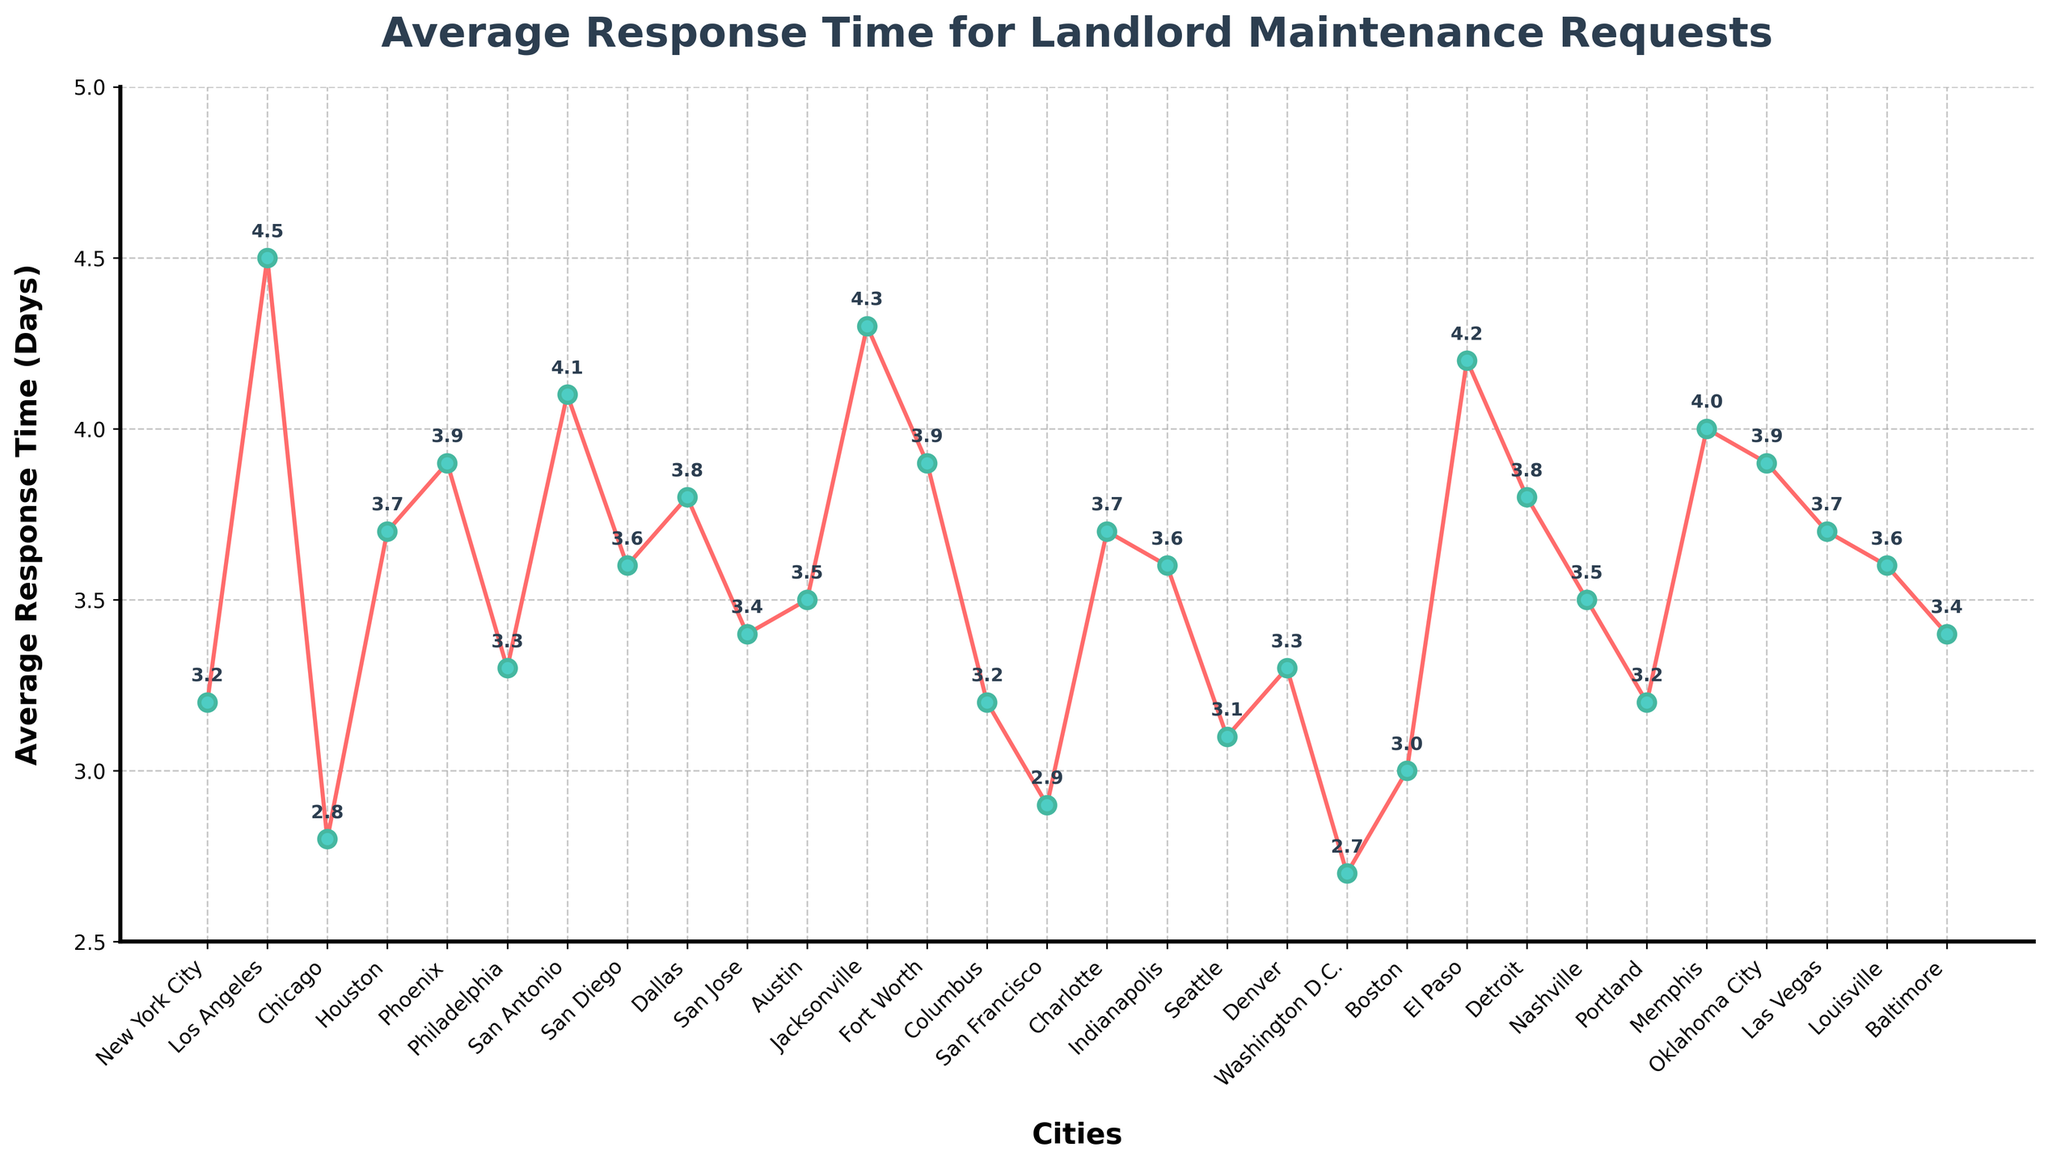what is the average response time in New York City? Refer to the data point for New York City on the chart. The plotted point corresponding to New York City's average response time shows 3.2 days.
Answer: 3.2 days Which city has the shortest average response time? To find the city with the shortest average response time, identify the lowest point on the line plot. The point for Washington D.C. is the lowest on the chart, indicating its average response time is the shortest at 2.7 days.
Answer: Washington D.C Which cities have an average response time greater than 4 days? To determine which cities have an average response time greater than 4 days, look at the points on the plot that are above the 4-day line. The cities are Los Angeles (4.5), Jacksonville (4.3), El Paso (4.2), and San Antonio (4.1).
Answer: Los Angeles, Jacksonville, El Paso, San Antonio What is the difference in average response times between Chicago and Los Angeles? The average response time for Chicago is 2.8 days, and for Los Angeles, it is 4.5 days. Calculate the difference: 4.5 - 2.8 = 1.7 days.
Answer: 1.7 days Which city has a longer average response time, Boston or Seattle? Find the points for Boston and Seattle on the plot. Boston's point is at 3.0 days, and Seattle's is at 3.1 days. Comparing these, Seattle has a slightly longer response time.
Answer: Seattle What is the range of the average response times on the plot? To find the range, identify the highest and lowest average response times on the plot. The highest is 4.5 days (Los Angeles), and the lowest is 2.7 days (Washington D.C.). The range is 4.5 - 2.7 = 1.8 days.
Answer: 1.8 days How many cities have an average response time less than 3 days? Count the number of points on the plot that are below the 3-day line. The cities are Chicago (2.8), San Francisco (2.9), Washington D.C. (2.7), and Boston (3.0). Thus, 3 cities.
Answer: 4 cities Which cities have an equal average response time of 3.2 days? Identify points on the plot that align with 3.2 days. New York City and Columbus both have an average response time of 3.2 days.
Answer: New York City, Columbus What is the median average response time across all cities? To find the median value, list all the average response times in ascending order and locate the middle value. For 30 data points, the median would be the average of the 15th and 16th values. The values in order are: 2.7, 2.8, 2.9, 3.0, 3.1, 3.2, 3.2, 3.2, 3.3, 3.3, 3.4, 3.4, 3.5, 3.5, 3.6, 3.6, 3.6, 3.7, 3.7, 3.7, 3.7, 3.8, 3.8, 3.8, 3.9, 3.9, 3.9, 4.0, 4.1, 4.2, 4.3, 4.5. The 15th and 16th values are 3.6 and 3.6, so the median is 3.6.
Answer: 3.6 days 